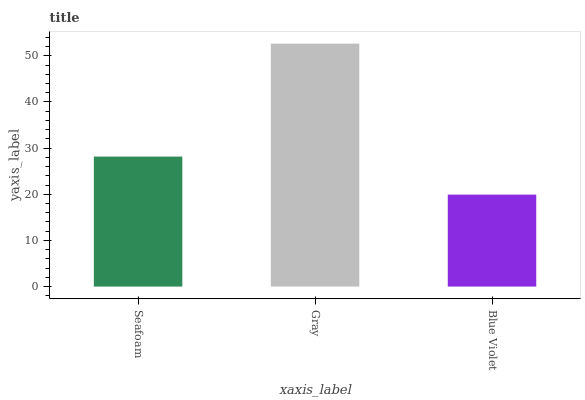Is Blue Violet the minimum?
Answer yes or no. Yes. Is Gray the maximum?
Answer yes or no. Yes. Is Gray the minimum?
Answer yes or no. No. Is Blue Violet the maximum?
Answer yes or no. No. Is Gray greater than Blue Violet?
Answer yes or no. Yes. Is Blue Violet less than Gray?
Answer yes or no. Yes. Is Blue Violet greater than Gray?
Answer yes or no. No. Is Gray less than Blue Violet?
Answer yes or no. No. Is Seafoam the high median?
Answer yes or no. Yes. Is Seafoam the low median?
Answer yes or no. Yes. Is Gray the high median?
Answer yes or no. No. Is Gray the low median?
Answer yes or no. No. 